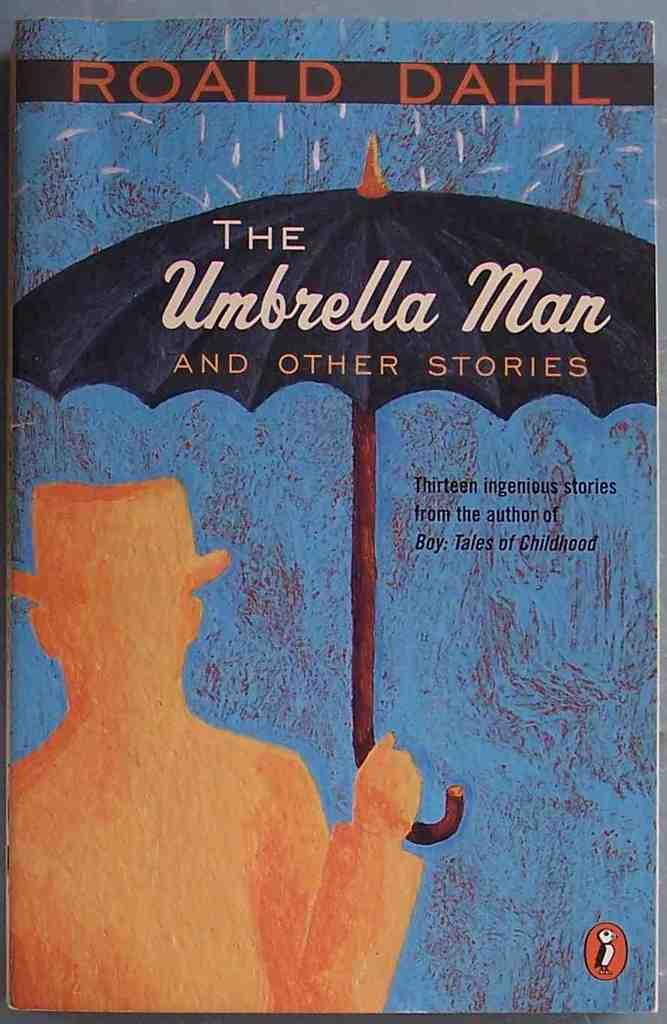<image>
Give a short and clear explanation of the subsequent image. A book of stories by Roald Dahl titled "The Umbrella Man and Other Stories" 